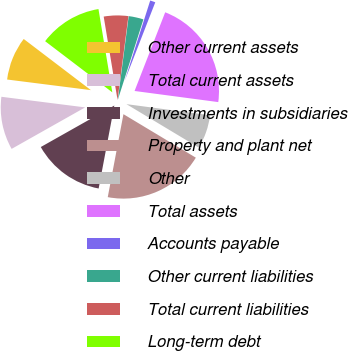<chart> <loc_0><loc_0><loc_500><loc_500><pie_chart><fcel>Other current assets<fcel>Total current assets<fcel>Investments in subsidiaries<fcel>Property and plant net<fcel>Other<fcel>Total assets<fcel>Accounts payable<fcel>Other current liabilities<fcel>Total current liabilities<fcel>Long-term debt<nl><fcel>8.35%<fcel>10.18%<fcel>13.85%<fcel>19.36%<fcel>6.51%<fcel>21.19%<fcel>1.01%<fcel>2.84%<fcel>4.68%<fcel>12.02%<nl></chart> 